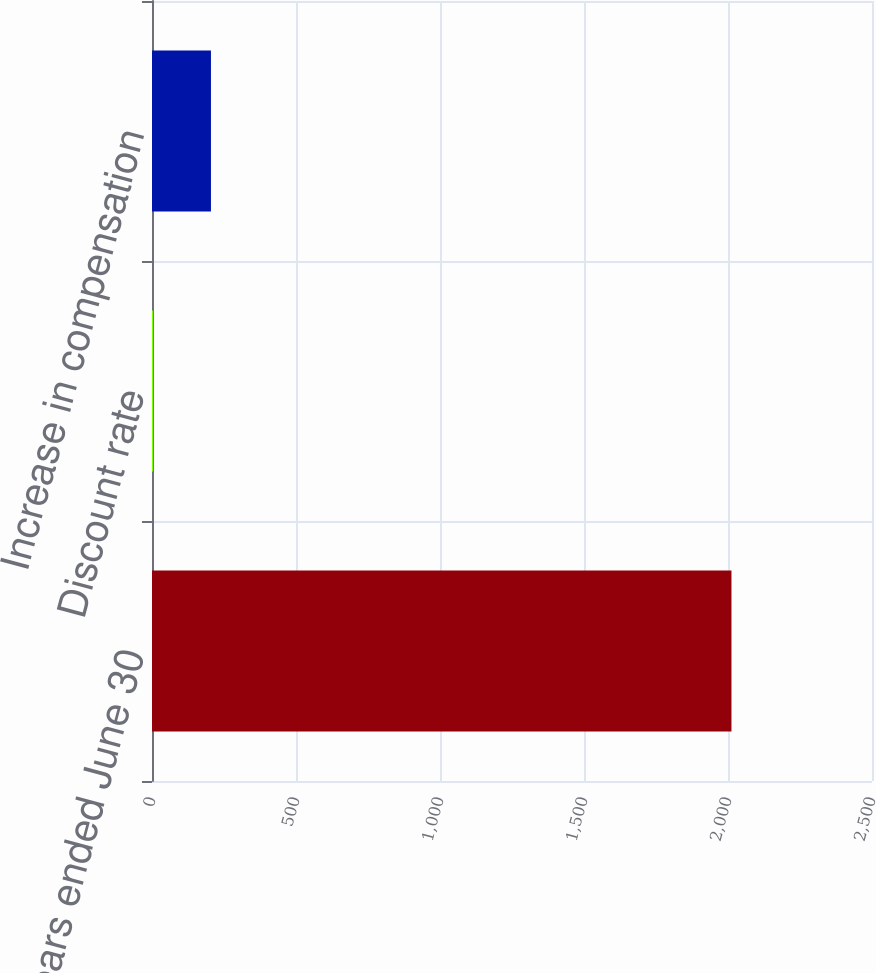Convert chart to OTSL. <chart><loc_0><loc_0><loc_500><loc_500><bar_chart><fcel>Years ended June 30<fcel>Discount rate<fcel>Increase in compensation<nl><fcel>2012<fcel>3.9<fcel>204.71<nl></chart> 